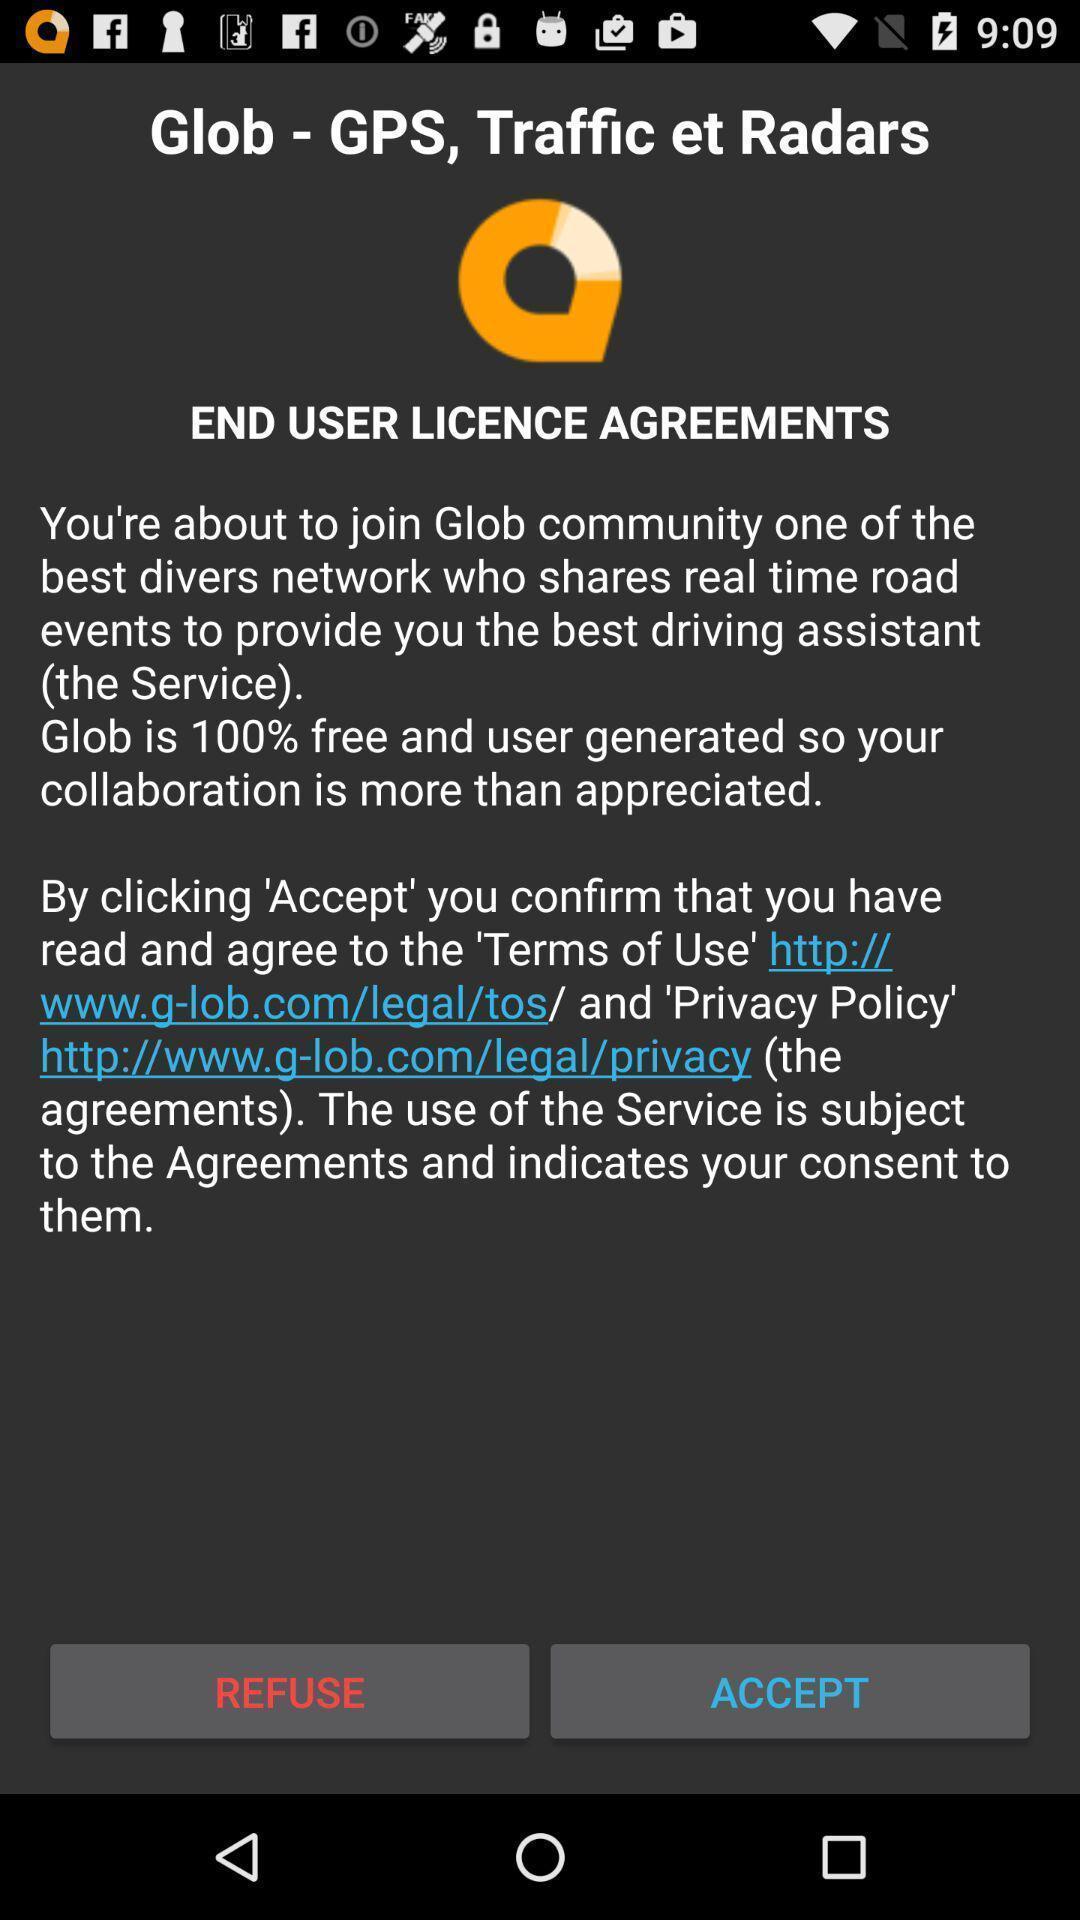Give me a summary of this screen capture. Screen showing refuse and accept options. 